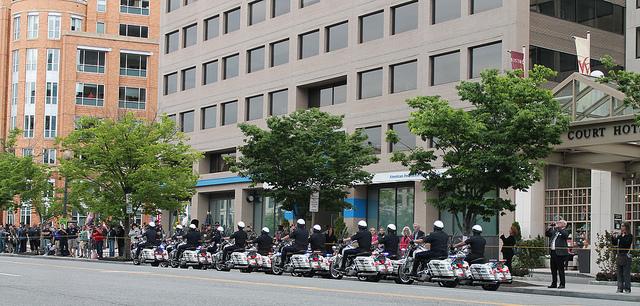Is there a rural or urban area?
Be succinct. Urban. Is there a taxi in this image?
Give a very brief answer. No. How many plants are on the right?
Keep it brief. 3. What are the police riding on?
Answer briefly. Motorcycles. How many inches did it rain?
Give a very brief answer. 0. How many trees can you see?
Concise answer only. 4. Is there a furniture store pictured?
Short answer required. No. How many bicycles are in this scene?
Write a very short answer. 0. What vehicle can be seen?
Concise answer only. Motorcycle. 